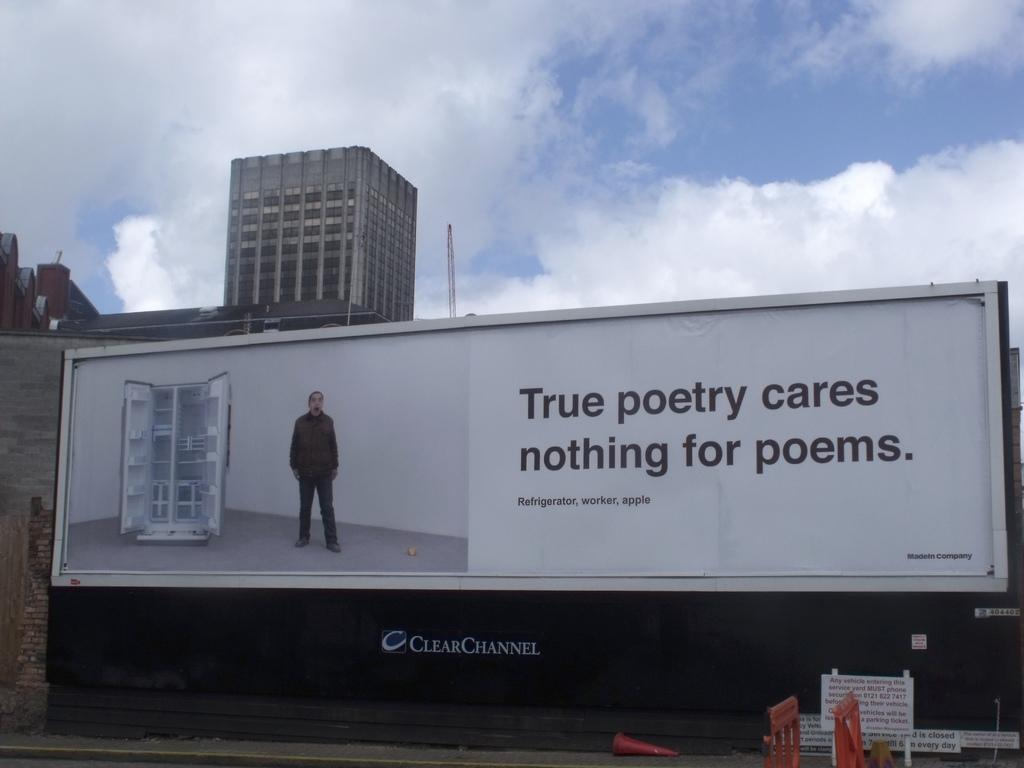What does true poetry care for?
Ensure brevity in your answer.  Nothing for poems. What service provider is advertised below the billboard?
Provide a succinct answer. Clearchannel. 